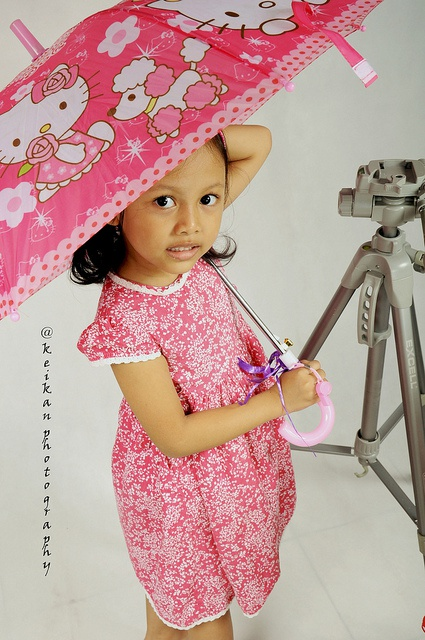Describe the objects in this image and their specific colors. I can see people in lightgray, lightpink, tan, and salmon tones and umbrella in lightgray, lightpink, salmon, and brown tones in this image. 